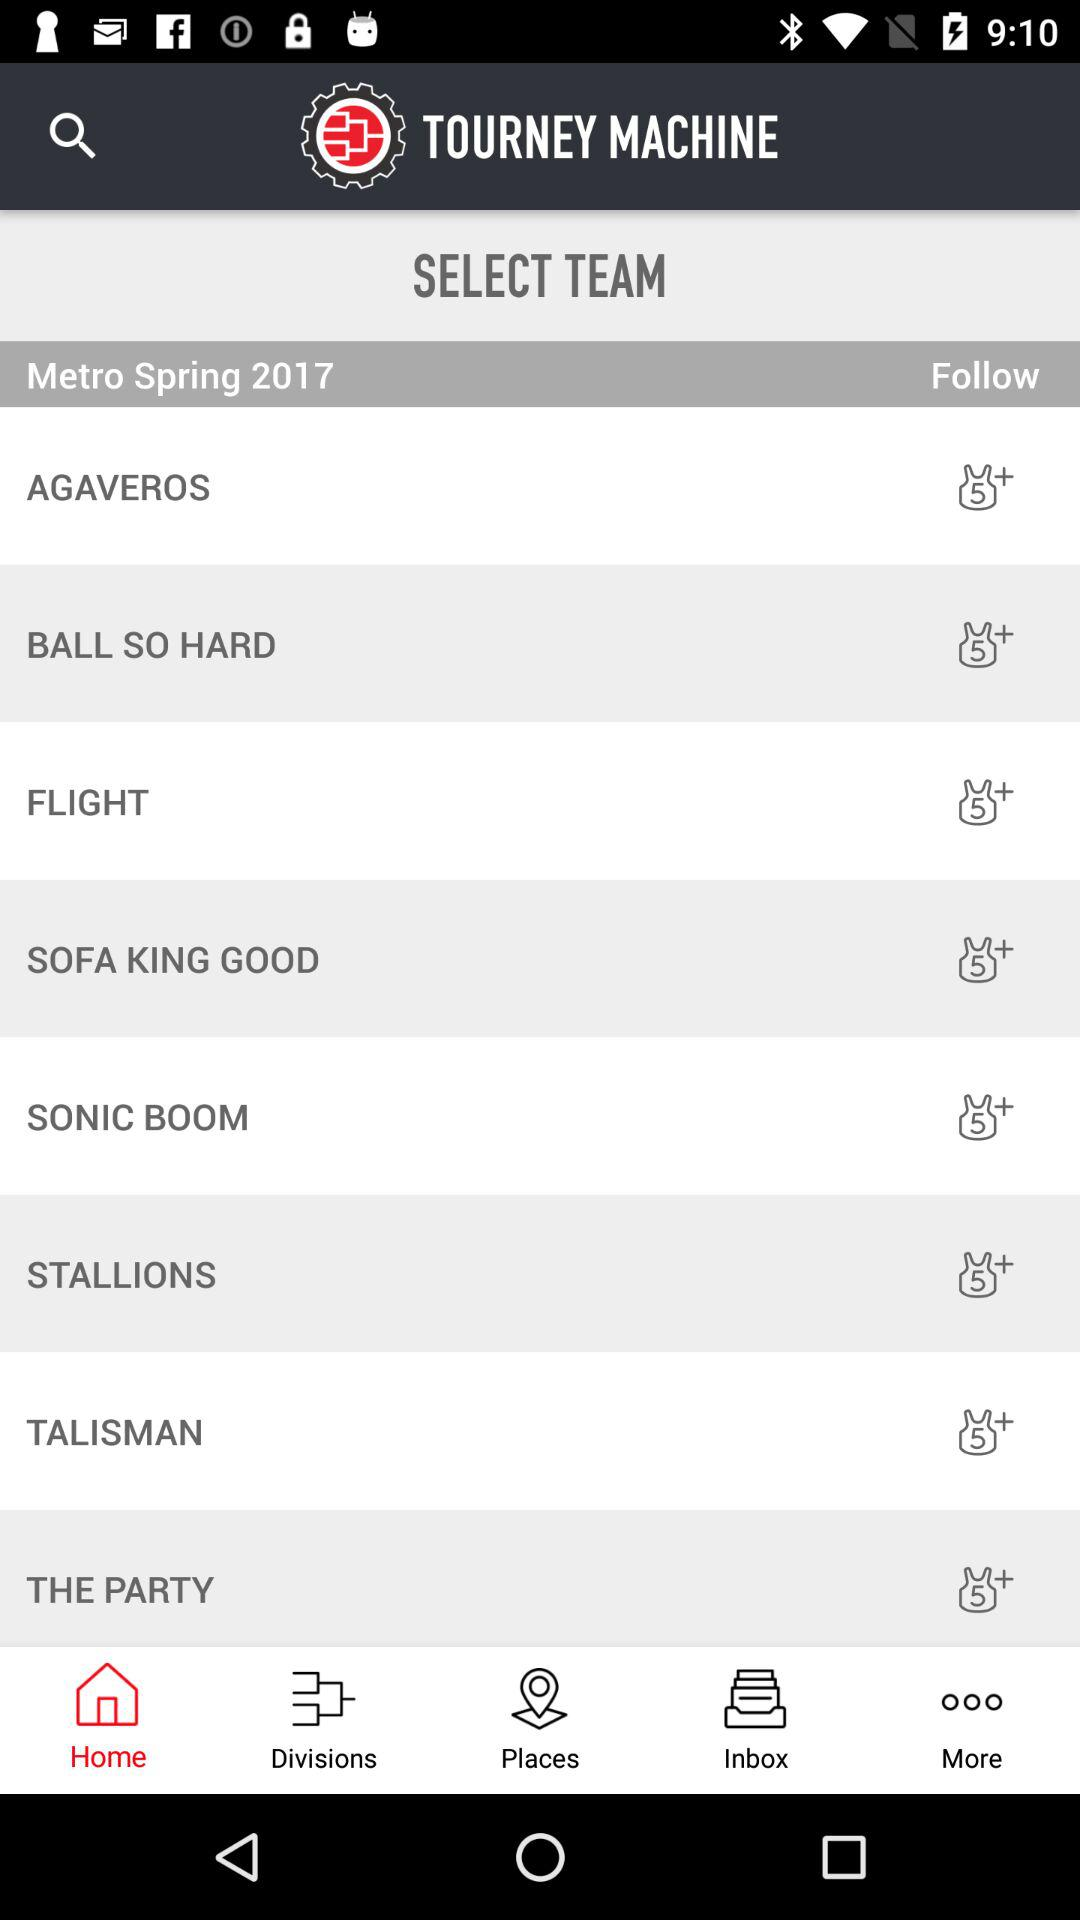Which option is selected in the taskbar? The selected option is "Home". 